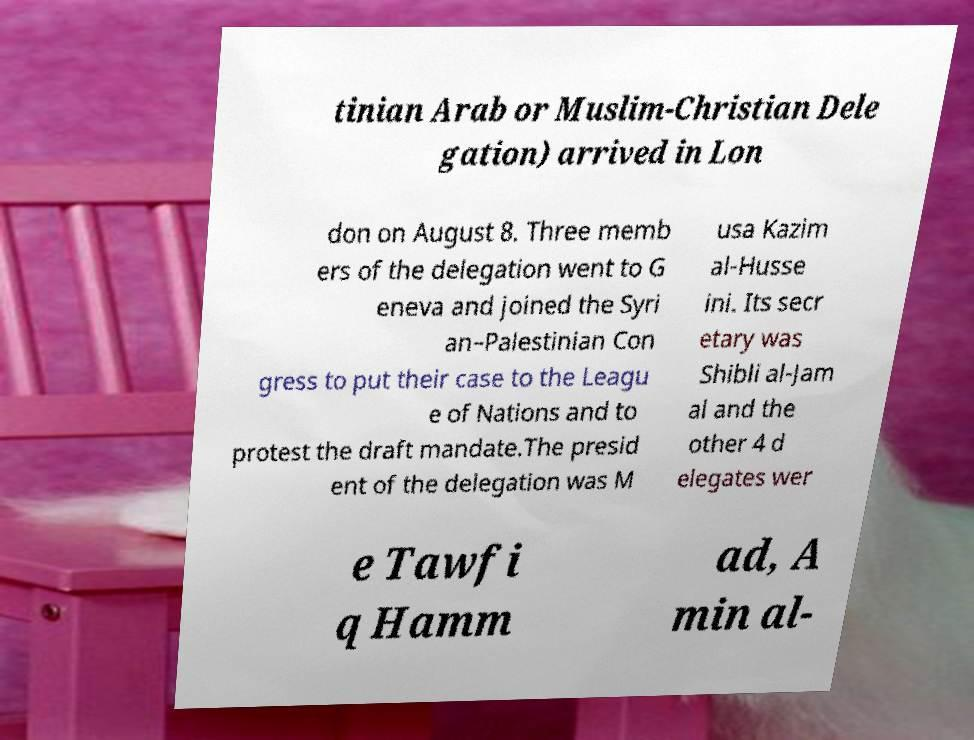Can you read and provide the text displayed in the image?This photo seems to have some interesting text. Can you extract and type it out for me? tinian Arab or Muslim-Christian Dele gation) arrived in Lon don on August 8. Three memb ers of the delegation went to G eneva and joined the Syri an–Palestinian Con gress to put their case to the Leagu e of Nations and to protest the draft mandate.The presid ent of the delegation was M usa Kazim al-Husse ini. Its secr etary was Shibli al-Jam al and the other 4 d elegates wer e Tawfi q Hamm ad, A min al- 